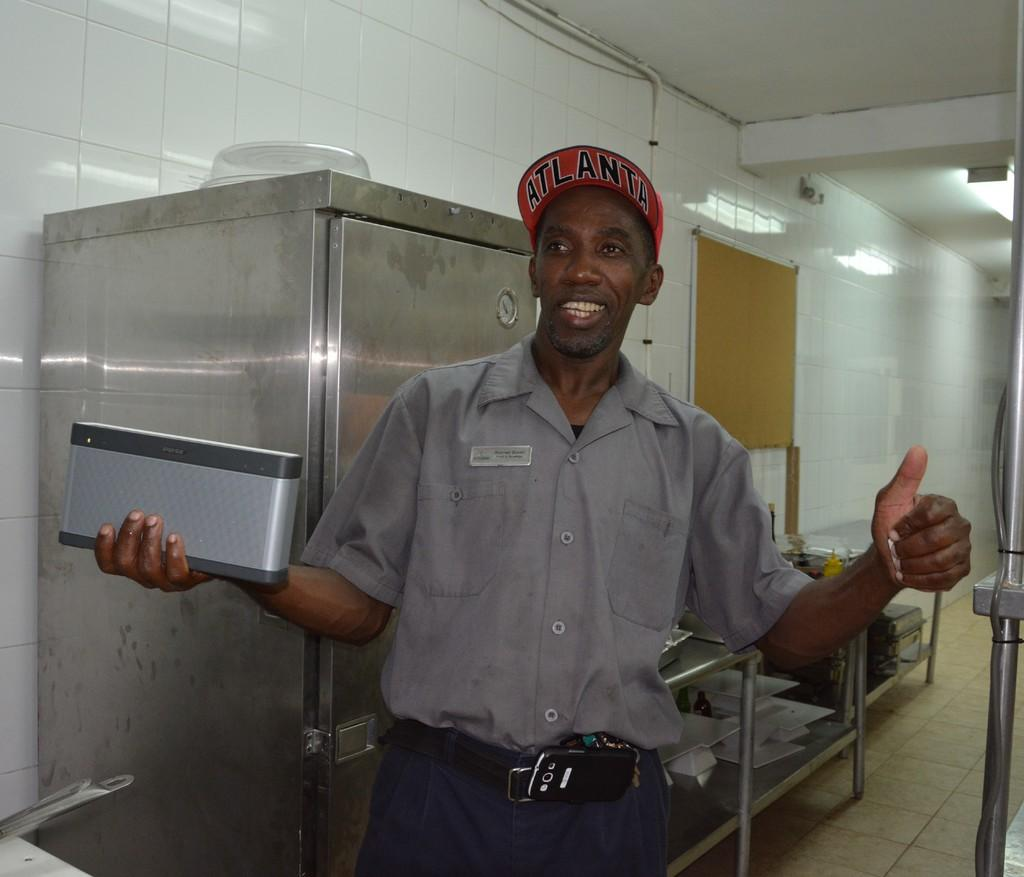<image>
Give a short and clear explanation of the subsequent image. A man giving a thumbs up while wearing an Atlanta hat. 